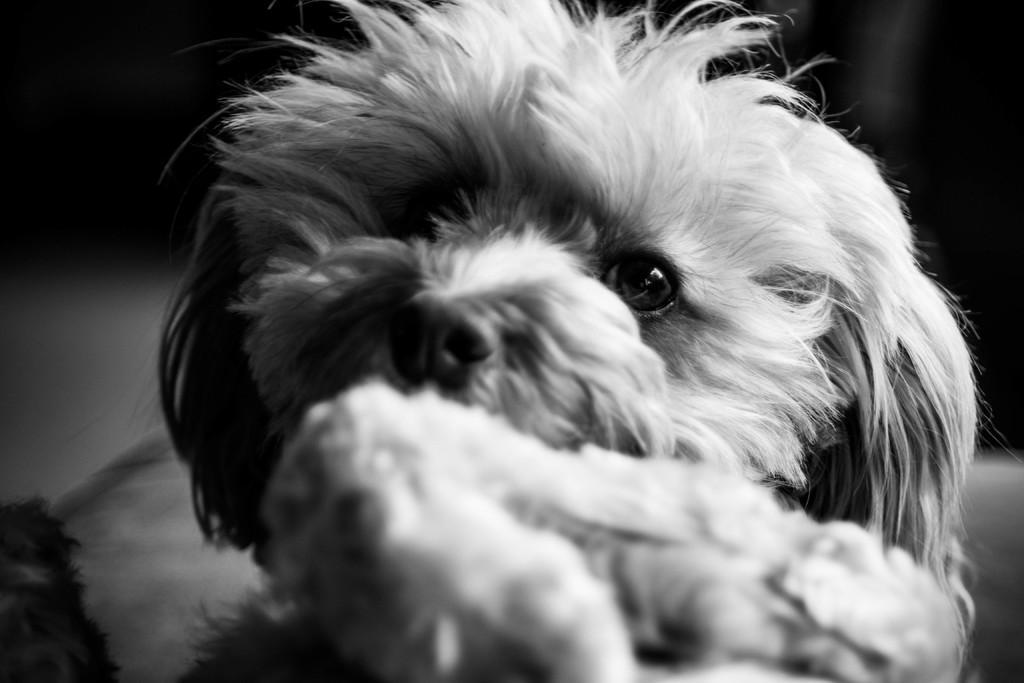Could you give a brief overview of what you see in this image? In the picture we can see a dog with full of fur near the dog we can see some food. 